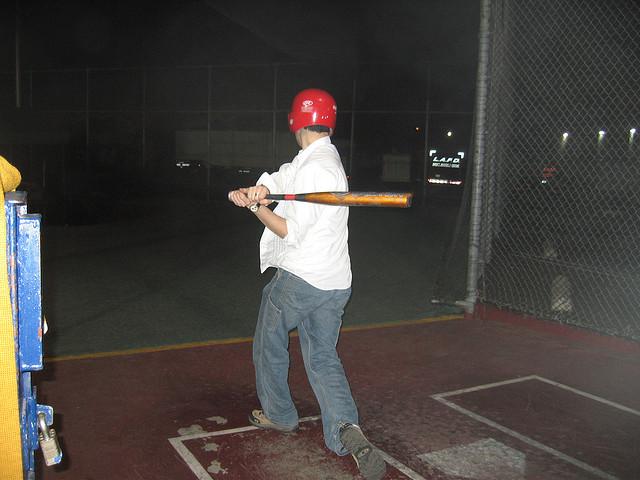Is this batter playing baseball or practicing?
Answer briefly. Practicing. Is the man featured in this picture wearing an official sporting uniform?
Short answer required. No. Is the man beginning or finishing his swing?
Concise answer only. Finishing. 